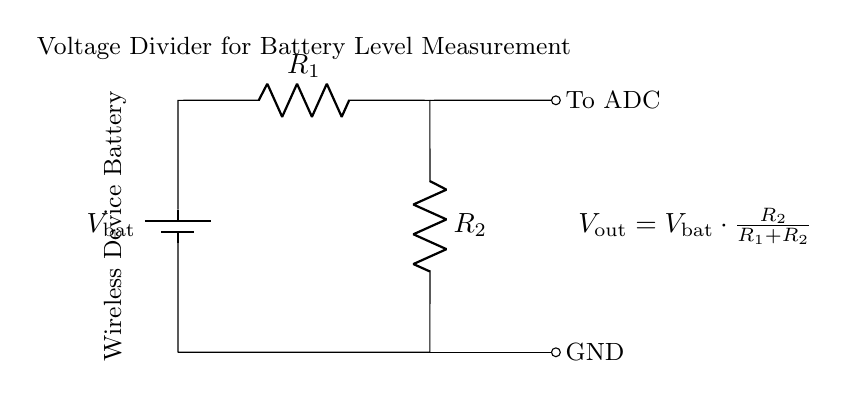What is the source voltage in this circuit? The source voltage is indicated as V_bat in the circuit diagram, which represents the voltage supplied by the wireless device battery.
Answer: V_bat What are the two resistors in this voltage divider? The two resistors present are labeled R_1 and R_2 in the circuit diagram, which are used to create the voltage division.
Answer: R_1 and R_2 What is the output voltage formula in this circuit? The output voltage, V_out, is given by the formula V_out = V_bat * (R_2 / (R_1 + R_2)), which shows how the voltage is divided between the two resistors.
Answer: V_out = V_bat * (R_2 / (R_1 + R_2)) How does changing R_2 affect V_out? If R_2 increases while R_1 remains constant, V_out will increase according to the voltage divider formula, as R_2 is in the numerator of the fraction. This makes V_out more responsive to variations in R_2.
Answer: Increases What happens to V_out if R_1 is much larger than R_2? If R_1 is much larger than R_2, then V_out will be much smaller than V_bat, approaching zero, as the voltage will be primarily dropped across R_1.
Answer: Approaches zero 